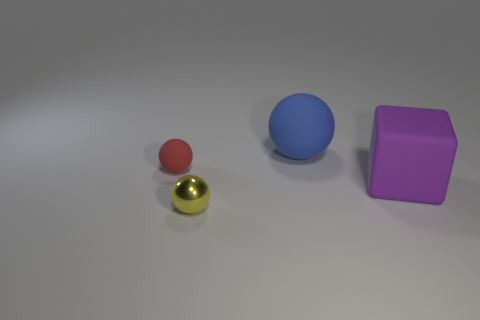Add 3 blue spheres. How many objects exist? 7 Subtract all balls. How many objects are left? 1 Subtract all small red things. Subtract all tiny red rubber objects. How many objects are left? 2 Add 1 blue things. How many blue things are left? 2 Add 1 big matte cylinders. How many big matte cylinders exist? 1 Subtract 1 yellow balls. How many objects are left? 3 